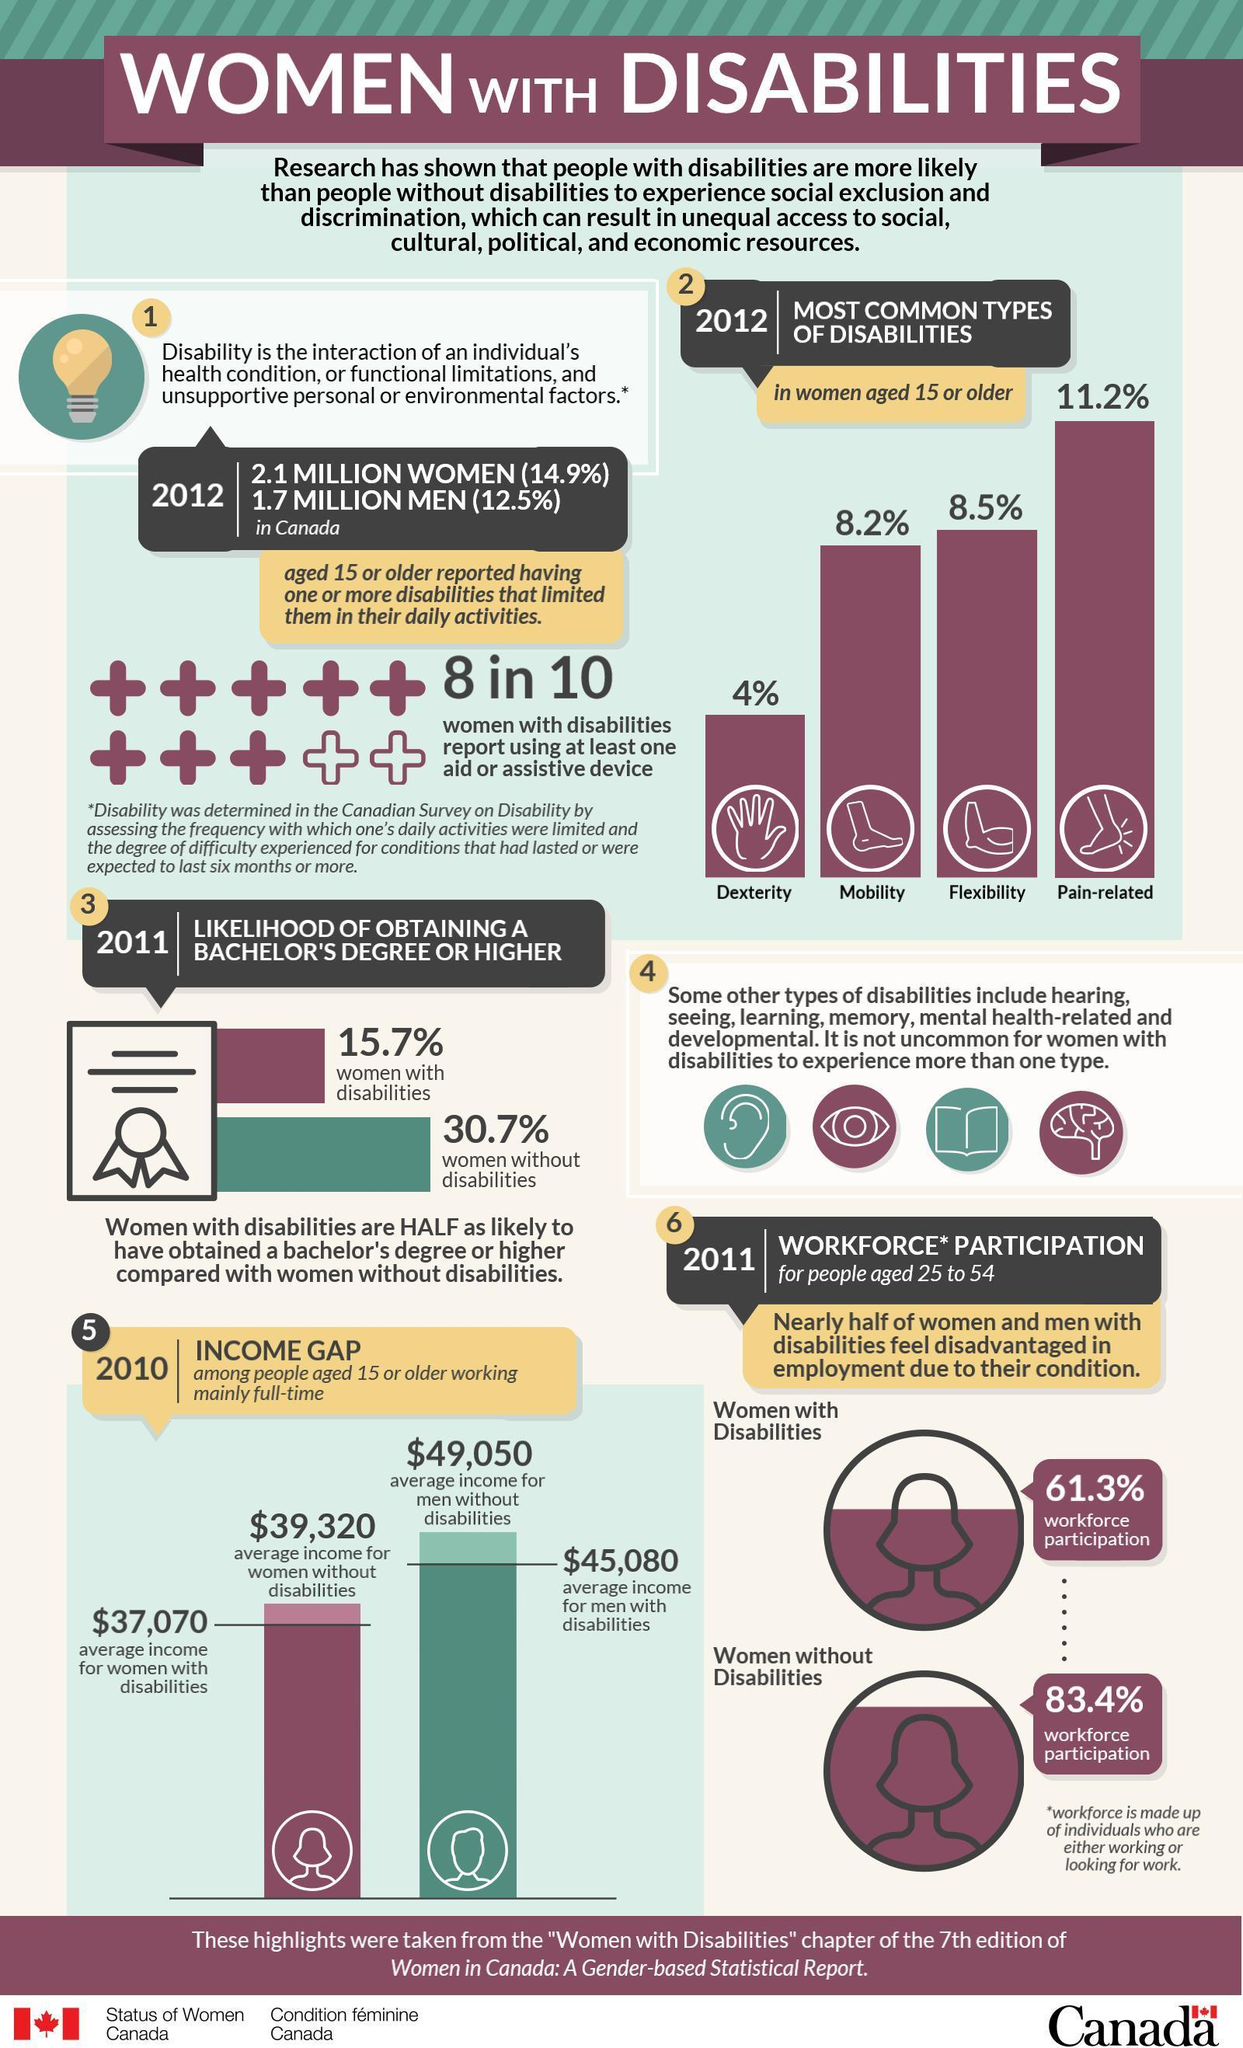How many different types of disability are there in women other than Flexibility?
Answer the question with a short phrase. 3 Which kind of disability is the second-highest among women? Flexibility What percentage of Canadian men are not disabled? 87.5 What percentage of disabled women have a high chance to pursue graduation? 15.7% What number of Canadian women are disabled? 2.1 million women Which kind of disability is the third-highest among women? Mobility 